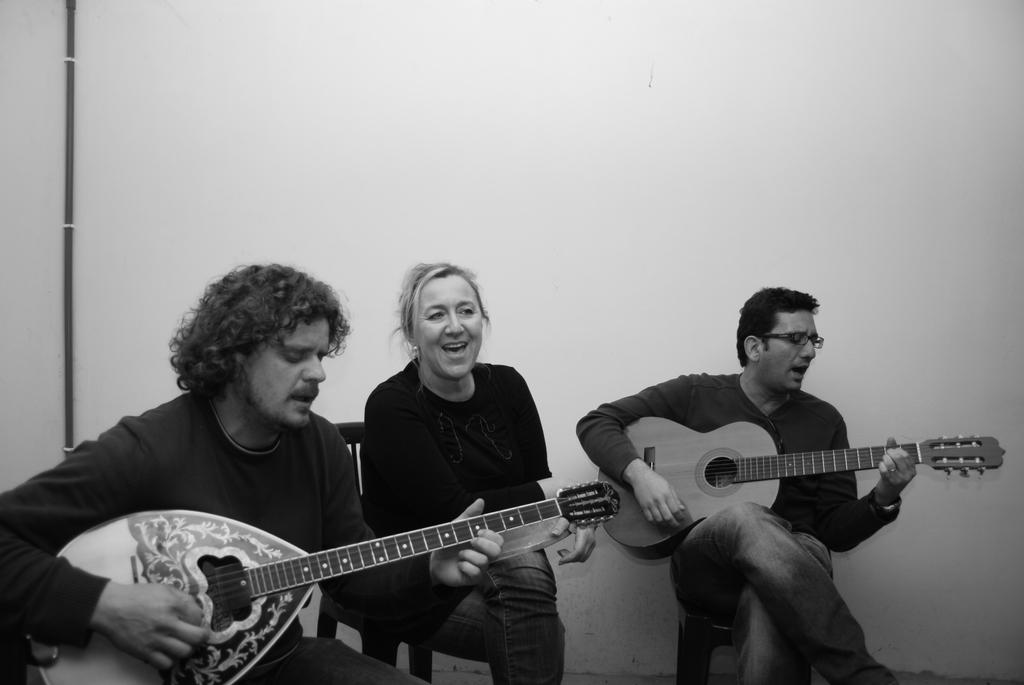What are the people in the image doing? The people in the image are sitting on chairs. What are the two men holding in their hands? The two men are holding guitars in their hands. What color scheme is used in the image? The image is in black and white color. Can you see any art pieces in the image? There is no mention of any art pieces in the image, so we cannot determine if any are present. What type of hair can be seen on the people in the image? The image is in black and white color, so it is difficult to determine the type of hair on the people in the image. 